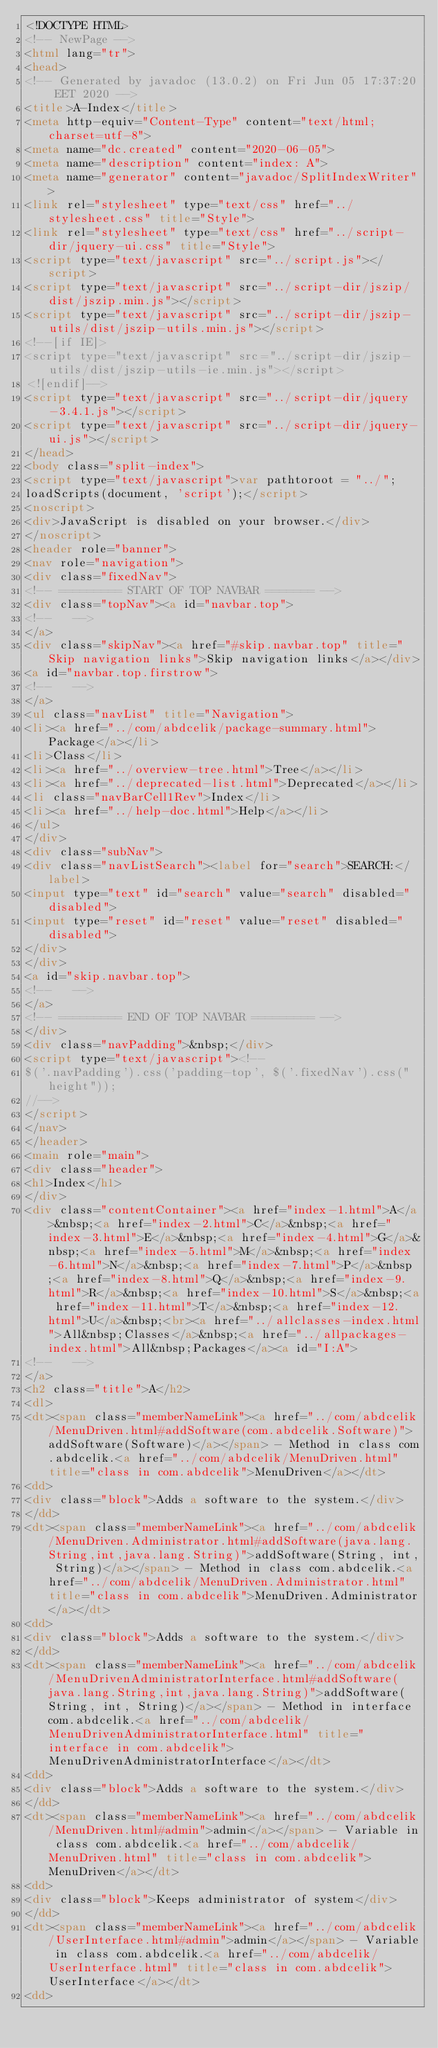Convert code to text. <code><loc_0><loc_0><loc_500><loc_500><_HTML_><!DOCTYPE HTML>
<!-- NewPage -->
<html lang="tr">
<head>
<!-- Generated by javadoc (13.0.2) on Fri Jun 05 17:37:20 EET 2020 -->
<title>A-Index</title>
<meta http-equiv="Content-Type" content="text/html; charset=utf-8">
<meta name="dc.created" content="2020-06-05">
<meta name="description" content="index: A">
<meta name="generator" content="javadoc/SplitIndexWriter">
<link rel="stylesheet" type="text/css" href="../stylesheet.css" title="Style">
<link rel="stylesheet" type="text/css" href="../script-dir/jquery-ui.css" title="Style">
<script type="text/javascript" src="../script.js"></script>
<script type="text/javascript" src="../script-dir/jszip/dist/jszip.min.js"></script>
<script type="text/javascript" src="../script-dir/jszip-utils/dist/jszip-utils.min.js"></script>
<!--[if IE]>
<script type="text/javascript" src="../script-dir/jszip-utils/dist/jszip-utils-ie.min.js"></script>
<![endif]-->
<script type="text/javascript" src="../script-dir/jquery-3.4.1.js"></script>
<script type="text/javascript" src="../script-dir/jquery-ui.js"></script>
</head>
<body class="split-index">
<script type="text/javascript">var pathtoroot = "../";
loadScripts(document, 'script');</script>
<noscript>
<div>JavaScript is disabled on your browser.</div>
</noscript>
<header role="banner">
<nav role="navigation">
<div class="fixedNav">
<!-- ========= START OF TOP NAVBAR ======= -->
<div class="topNav"><a id="navbar.top">
<!--   -->
</a>
<div class="skipNav"><a href="#skip.navbar.top" title="Skip navigation links">Skip navigation links</a></div>
<a id="navbar.top.firstrow">
<!--   -->
</a>
<ul class="navList" title="Navigation">
<li><a href="../com/abdcelik/package-summary.html">Package</a></li>
<li>Class</li>
<li><a href="../overview-tree.html">Tree</a></li>
<li><a href="../deprecated-list.html">Deprecated</a></li>
<li class="navBarCell1Rev">Index</li>
<li><a href="../help-doc.html">Help</a></li>
</ul>
</div>
<div class="subNav">
<div class="navListSearch"><label for="search">SEARCH:</label>
<input type="text" id="search" value="search" disabled="disabled">
<input type="reset" id="reset" value="reset" disabled="disabled">
</div>
</div>
<a id="skip.navbar.top">
<!--   -->
</a>
<!-- ========= END OF TOP NAVBAR ========= -->
</div>
<div class="navPadding">&nbsp;</div>
<script type="text/javascript"><!--
$('.navPadding').css('padding-top', $('.fixedNav').css("height"));
//-->
</script>
</nav>
</header>
<main role="main">
<div class="header">
<h1>Index</h1>
</div>
<div class="contentContainer"><a href="index-1.html">A</a>&nbsp;<a href="index-2.html">C</a>&nbsp;<a href="index-3.html">E</a>&nbsp;<a href="index-4.html">G</a>&nbsp;<a href="index-5.html">M</a>&nbsp;<a href="index-6.html">N</a>&nbsp;<a href="index-7.html">P</a>&nbsp;<a href="index-8.html">Q</a>&nbsp;<a href="index-9.html">R</a>&nbsp;<a href="index-10.html">S</a>&nbsp;<a href="index-11.html">T</a>&nbsp;<a href="index-12.html">U</a>&nbsp;<br><a href="../allclasses-index.html">All&nbsp;Classes</a>&nbsp;<a href="../allpackages-index.html">All&nbsp;Packages</a><a id="I:A">
<!--   -->
</a>
<h2 class="title">A</h2>
<dl>
<dt><span class="memberNameLink"><a href="../com/abdcelik/MenuDriven.html#addSoftware(com.abdcelik.Software)">addSoftware(Software)</a></span> - Method in class com.abdcelik.<a href="../com/abdcelik/MenuDriven.html" title="class in com.abdcelik">MenuDriven</a></dt>
<dd>
<div class="block">Adds a software to the system.</div>
</dd>
<dt><span class="memberNameLink"><a href="../com/abdcelik/MenuDriven.Administrator.html#addSoftware(java.lang.String,int,java.lang.String)">addSoftware(String, int, String)</a></span> - Method in class com.abdcelik.<a href="../com/abdcelik/MenuDriven.Administrator.html" title="class in com.abdcelik">MenuDriven.Administrator</a></dt>
<dd>
<div class="block">Adds a software to the system.</div>
</dd>
<dt><span class="memberNameLink"><a href="../com/abdcelik/MenuDrivenAdministratorInterface.html#addSoftware(java.lang.String,int,java.lang.String)">addSoftware(String, int, String)</a></span> - Method in interface com.abdcelik.<a href="../com/abdcelik/MenuDrivenAdministratorInterface.html" title="interface in com.abdcelik">MenuDrivenAdministratorInterface</a></dt>
<dd>
<div class="block">Adds a software to the system.</div>
</dd>
<dt><span class="memberNameLink"><a href="../com/abdcelik/MenuDriven.html#admin">admin</a></span> - Variable in class com.abdcelik.<a href="../com/abdcelik/MenuDriven.html" title="class in com.abdcelik">MenuDriven</a></dt>
<dd>
<div class="block">Keeps administrator of system</div>
</dd>
<dt><span class="memberNameLink"><a href="../com/abdcelik/UserInterface.html#admin">admin</a></span> - Variable in class com.abdcelik.<a href="../com/abdcelik/UserInterface.html" title="class in com.abdcelik">UserInterface</a></dt>
<dd></code> 